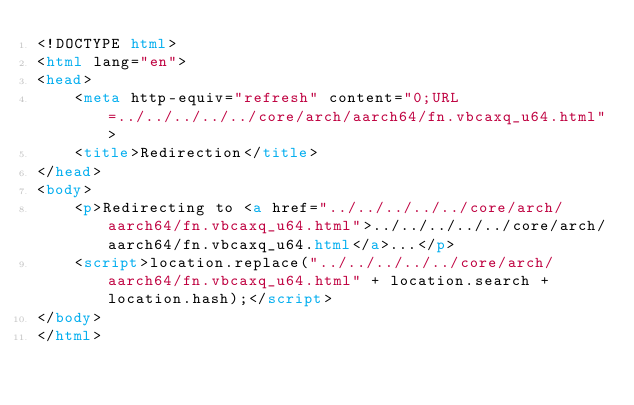<code> <loc_0><loc_0><loc_500><loc_500><_HTML_><!DOCTYPE html>
<html lang="en">
<head>
    <meta http-equiv="refresh" content="0;URL=../../../../../core/arch/aarch64/fn.vbcaxq_u64.html">
    <title>Redirection</title>
</head>
<body>
    <p>Redirecting to <a href="../../../../../core/arch/aarch64/fn.vbcaxq_u64.html">../../../../../core/arch/aarch64/fn.vbcaxq_u64.html</a>...</p>
    <script>location.replace("../../../../../core/arch/aarch64/fn.vbcaxq_u64.html" + location.search + location.hash);</script>
</body>
</html></code> 